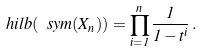Convert formula to latex. <formula><loc_0><loc_0><loc_500><loc_500>\ h i l b ( \ s y m ( X _ { n } ) ) = \prod _ { i = 1 } ^ { n } \frac { 1 } { 1 - t ^ { i } } \, .</formula> 